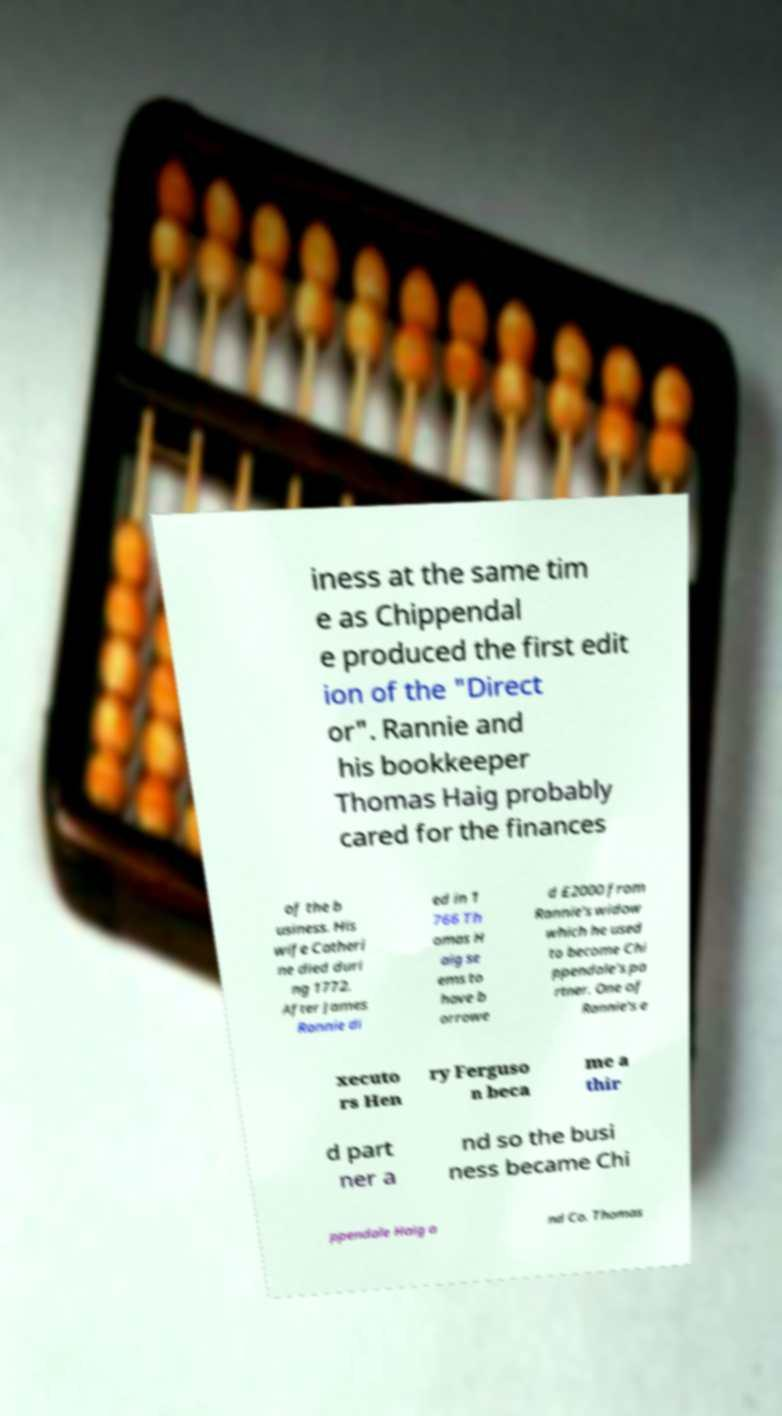Could you assist in decoding the text presented in this image and type it out clearly? iness at the same tim e as Chippendal e produced the first edit ion of the "Direct or". Rannie and his bookkeeper Thomas Haig probably cared for the finances of the b usiness. His wife Catheri ne died duri ng 1772. After James Rannie di ed in 1 766 Th omas H aig se ems to have b orrowe d £2000 from Rannie's widow which he used to become Chi ppendale's pa rtner. One of Rannie's e xecuto rs Hen ry Ferguso n beca me a thir d part ner a nd so the busi ness became Chi ppendale Haig a nd Co. Thomas 